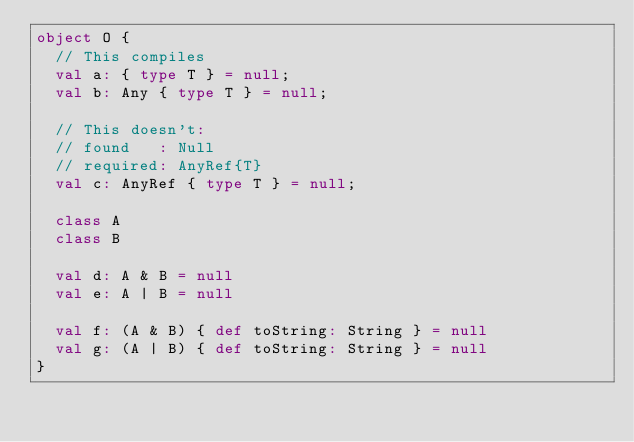<code> <loc_0><loc_0><loc_500><loc_500><_Scala_>object O {
  // This compiles
  val a: { type T } = null;
  val b: Any { type T } = null;

  // This doesn't:
  // found   : Null
  // required: AnyRef{T}
  val c: AnyRef { type T } = null;

  class A
  class B

  val d: A & B = null
  val e: A | B = null

  val f: (A & B) { def toString: String } = null
  val g: (A | B) { def toString: String } = null
}
</code> 